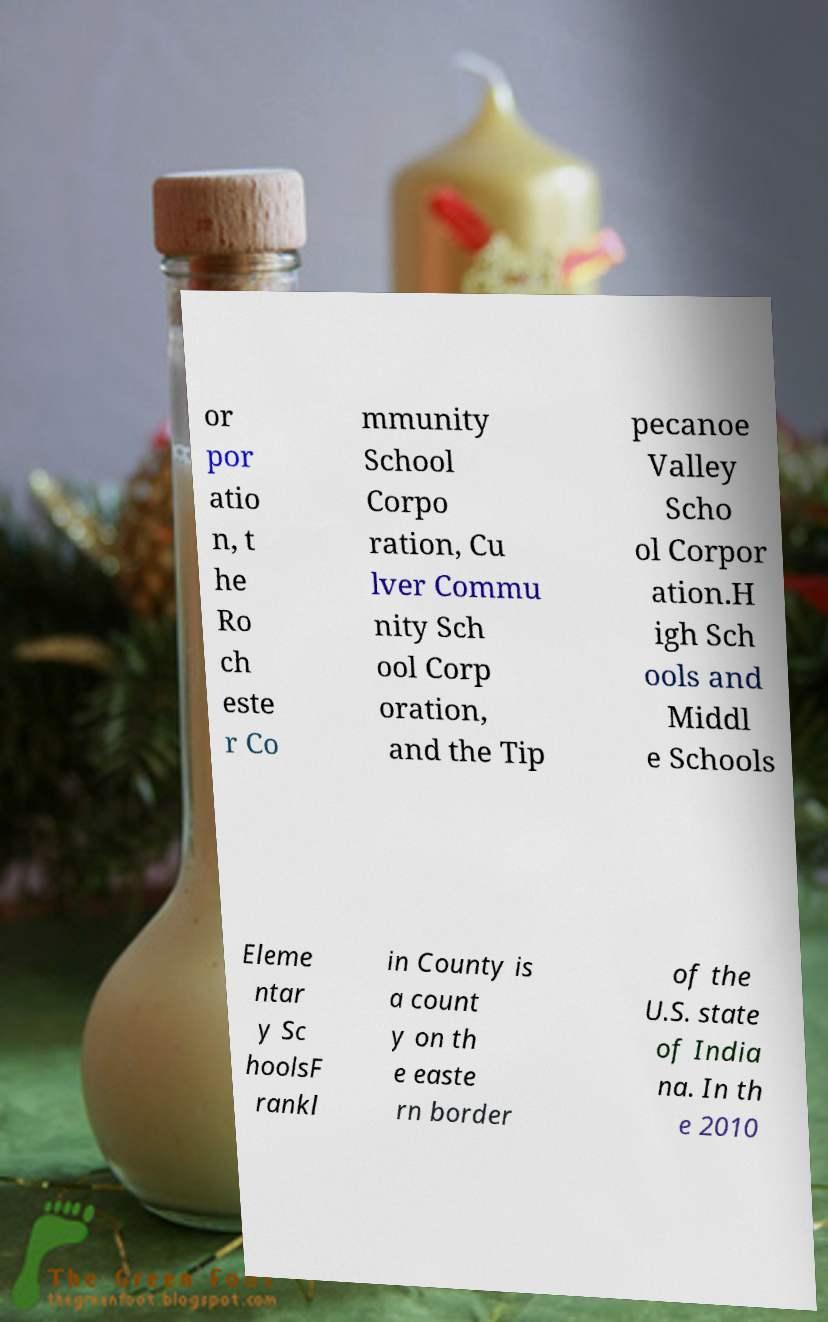Please read and relay the text visible in this image. What does it say? or por atio n, t he Ro ch este r Co mmunity School Corpo ration, Cu lver Commu nity Sch ool Corp oration, and the Tip pecanoe Valley Scho ol Corpor ation.H igh Sch ools and Middl e Schools Eleme ntar y Sc hoolsF rankl in County is a count y on th e easte rn border of the U.S. state of India na. In th e 2010 